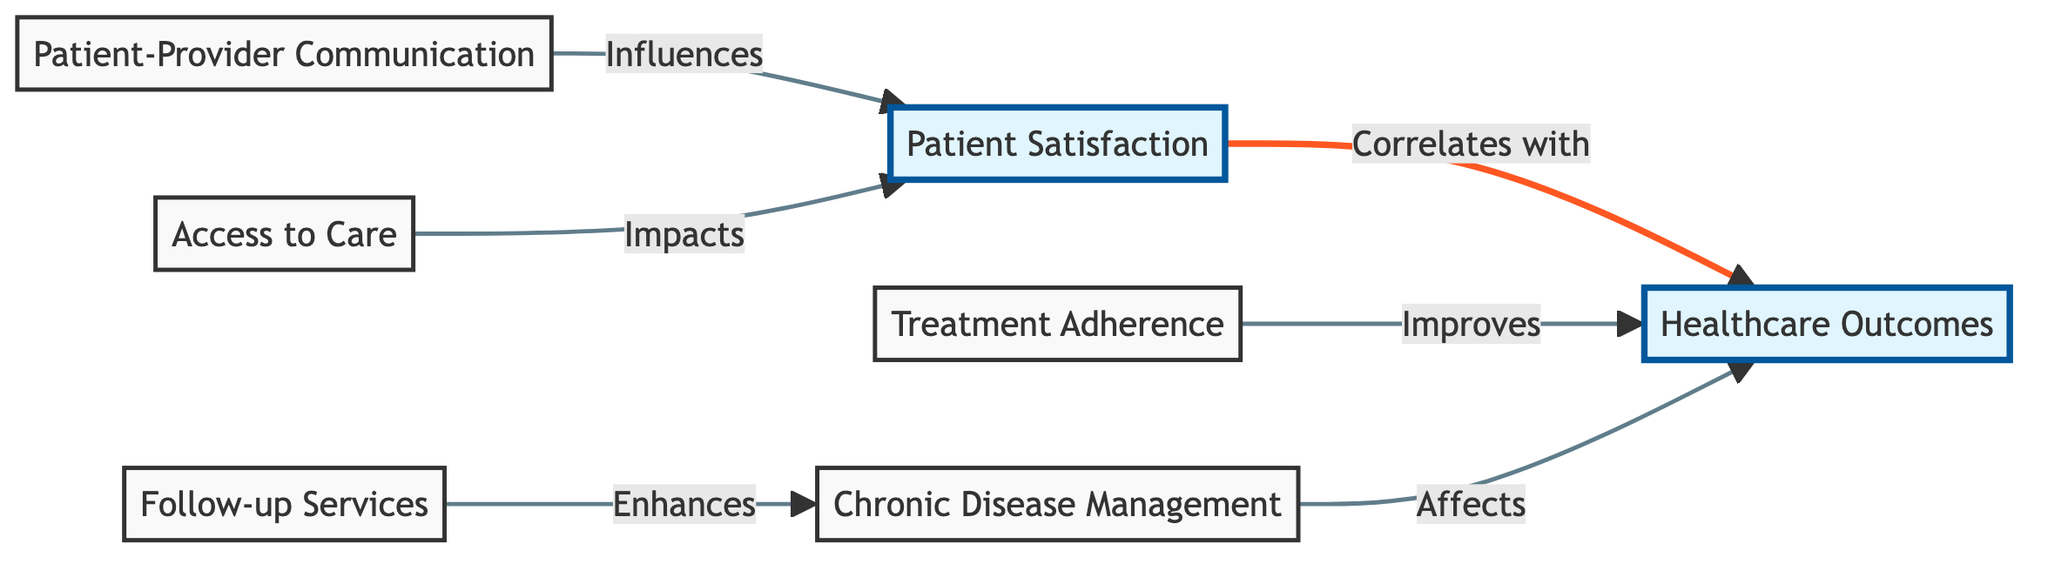What is the primary focus of the diagram? The diagram centers around the correlation between "Patient Satisfaction" and "Healthcare Outcomes". The two highlighted nodes represent the main concepts being analyzed in the correlation analysis.
Answer: Patient Satisfaction and Healthcare Outcomes How many influencing factors are shown in the diagram? There are five influencing factors represented by nodes that lead to "Patient Satisfaction". Each factor, such as "Patient-Provider Communication" and "Access to Care", is connected to the primary concept of patient satisfaction.
Answer: 5 Which factor directly correlates with "Healthcare Outcomes"? The factor "Treatment Adherence" is specified as improving "Healthcare Outcomes", indicating a direct relationship and effect.
Answer: Treatment Adherence What influences "Patient Satisfaction" in the diagram? "Patient-Provider Communication" and "Access to Care" lead to "Patient Satisfaction", showing how these elements affect patient perceptions and experiences.
Answer: Patient-Provider Communication, Access to Care Which two factors are related to "Chronic Disease Management"? "Follow-up Services" enhances "Chronic Disease Management", indicating that proper follow-up can improve management of chronic conditions.
Answer: Follow-up Services Describe the flow from "Follow-up Services" to "Healthcare Outcomes". The path goes from "Follow-up Services" to "Chronic Disease Management", which then affects "Healthcare Outcomes", suggesting that effective follow-up contributes to better management of chronic diseases, ultimately leading to favorable healthcare outcomes.
Answer: Follow-up Services to Chronic Disease Management to Healthcare Outcomes What is a consequence of higher "Treatment Adherence"? Higher "Treatment Adherence" improves "Healthcare Outcomes", indicating that sticking to prescribed treatments is beneficial for overall health results.
Answer: Improves Healthcare Outcomes Is "Access to Care" directly linked to "Healthcare Outcomes"? No, "Access to Care" influences "Patient Satisfaction" but does not have a direct link to "Healthcare Outcomes" in this diagram.
Answer: No Which node has the strongest influence in terms of arrows leading into "Patient Satisfaction"? The node with the strongest influence is "Patient-Provider Communication", it has a direct influence, showing its critical role in enhancing patient satisfaction.
Answer: Patient-Provider Communication 